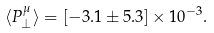<formula> <loc_0><loc_0><loc_500><loc_500>\langle P _ { \perp } ^ { \mu } \rangle = [ - 3 . 1 \pm 5 . 3 ] \times 1 0 ^ { - 3 } .</formula> 